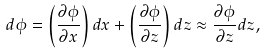<formula> <loc_0><loc_0><loc_500><loc_500>d \phi = \left ( \frac { \partial \phi } { \partial x } \right ) d x + \left ( \frac { \partial \phi } { \partial z } \right ) d z \approx \frac { \partial \phi } { \partial z } d z ,</formula> 